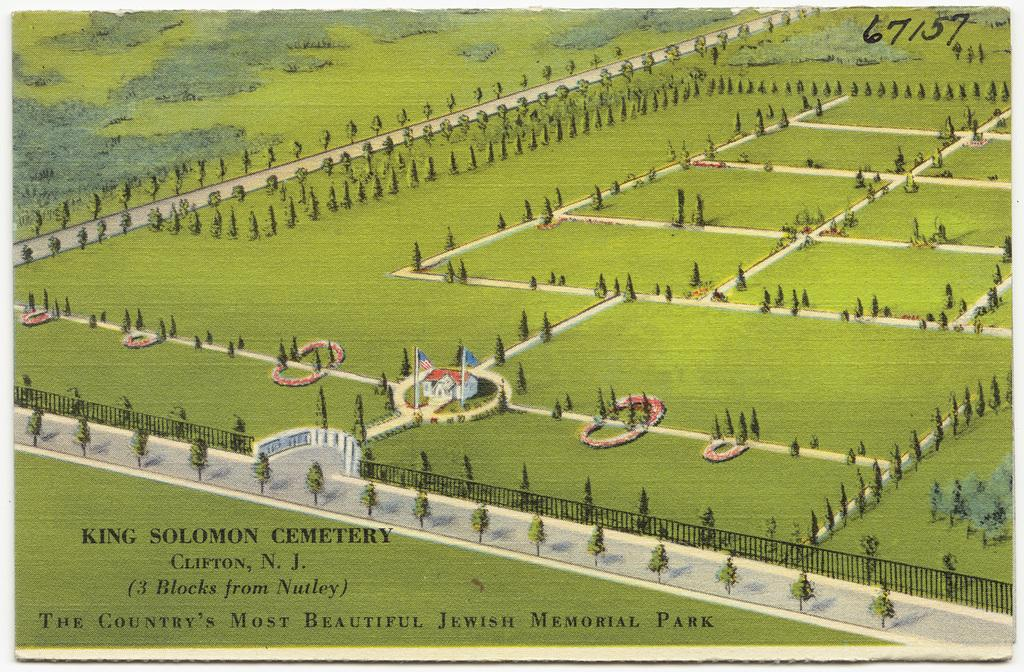<image>
Give a short and clear explanation of the subsequent image. A painting featuring the green fields of King Solomon Cemetery. 